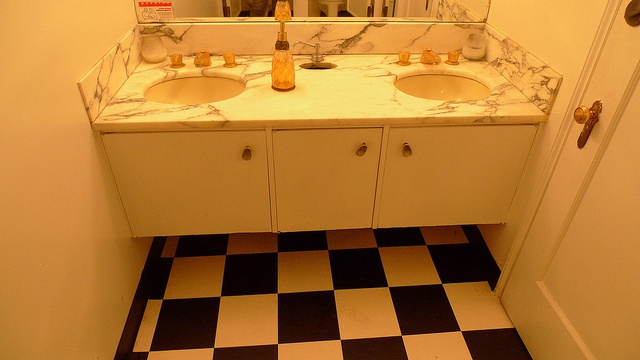Describe the objects in this image and their specific colors. I can see sink in orange and red tones, sink in orange and gold tones, bottle in orange, brown, and maroon tones, vase in orange tones, and vase in orange and olive tones in this image. 